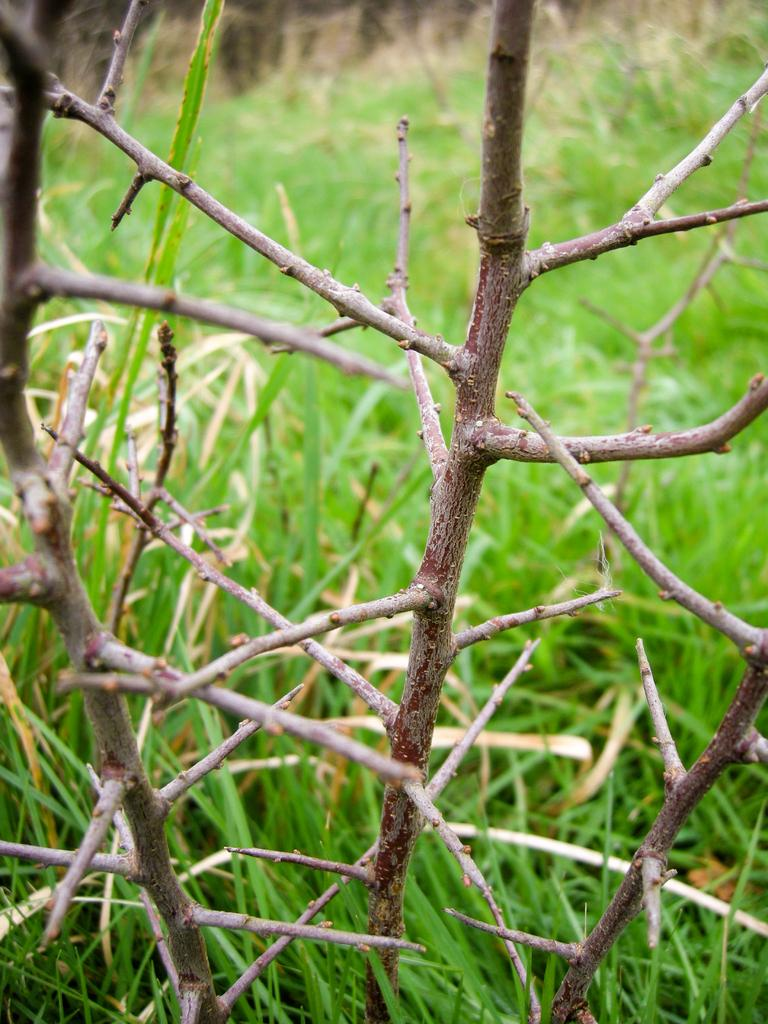What is the main subject in the foreground of the image? There is a stem of a plant in the foreground of the image. What type of vegetation can be seen at the bottom of the image? There is grass visible at the bottom of the image. What type of fork can be seen in the image? There is no fork present in the image. 